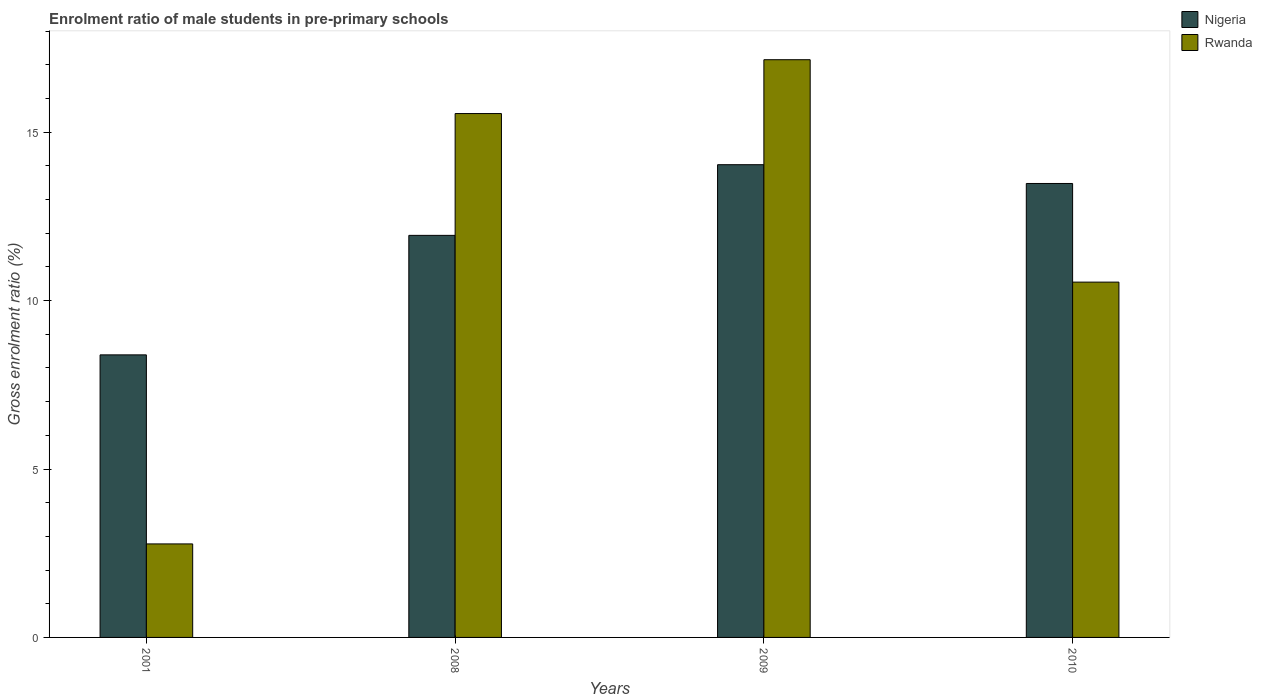How many groups of bars are there?
Your answer should be very brief. 4. Are the number of bars per tick equal to the number of legend labels?
Your answer should be very brief. Yes. How many bars are there on the 2nd tick from the left?
Your answer should be compact. 2. What is the label of the 4th group of bars from the left?
Provide a succinct answer. 2010. In how many cases, is the number of bars for a given year not equal to the number of legend labels?
Keep it short and to the point. 0. What is the enrolment ratio of male students in pre-primary schools in Nigeria in 2010?
Offer a terse response. 13.48. Across all years, what is the maximum enrolment ratio of male students in pre-primary schools in Nigeria?
Make the answer very short. 14.04. Across all years, what is the minimum enrolment ratio of male students in pre-primary schools in Rwanda?
Give a very brief answer. 2.78. In which year was the enrolment ratio of male students in pre-primary schools in Nigeria maximum?
Make the answer very short. 2009. In which year was the enrolment ratio of male students in pre-primary schools in Nigeria minimum?
Your answer should be very brief. 2001. What is the total enrolment ratio of male students in pre-primary schools in Nigeria in the graph?
Offer a terse response. 47.84. What is the difference between the enrolment ratio of male students in pre-primary schools in Nigeria in 2008 and that in 2010?
Ensure brevity in your answer.  -1.54. What is the difference between the enrolment ratio of male students in pre-primary schools in Rwanda in 2008 and the enrolment ratio of male students in pre-primary schools in Nigeria in 2001?
Provide a short and direct response. 7.16. What is the average enrolment ratio of male students in pre-primary schools in Rwanda per year?
Keep it short and to the point. 11.51. In the year 2010, what is the difference between the enrolment ratio of male students in pre-primary schools in Rwanda and enrolment ratio of male students in pre-primary schools in Nigeria?
Make the answer very short. -2.93. What is the ratio of the enrolment ratio of male students in pre-primary schools in Rwanda in 2008 to that in 2009?
Ensure brevity in your answer.  0.91. Is the difference between the enrolment ratio of male students in pre-primary schools in Rwanda in 2009 and 2010 greater than the difference between the enrolment ratio of male students in pre-primary schools in Nigeria in 2009 and 2010?
Provide a succinct answer. Yes. What is the difference between the highest and the second highest enrolment ratio of male students in pre-primary schools in Nigeria?
Provide a short and direct response. 0.56. What is the difference between the highest and the lowest enrolment ratio of male students in pre-primary schools in Nigeria?
Keep it short and to the point. 5.65. In how many years, is the enrolment ratio of male students in pre-primary schools in Nigeria greater than the average enrolment ratio of male students in pre-primary schools in Nigeria taken over all years?
Your answer should be compact. 2. Is the sum of the enrolment ratio of male students in pre-primary schools in Nigeria in 2009 and 2010 greater than the maximum enrolment ratio of male students in pre-primary schools in Rwanda across all years?
Your answer should be very brief. Yes. What does the 2nd bar from the left in 2009 represents?
Your answer should be very brief. Rwanda. What does the 1st bar from the right in 2001 represents?
Provide a succinct answer. Rwanda. How many bars are there?
Offer a very short reply. 8. How many years are there in the graph?
Offer a terse response. 4. What is the difference between two consecutive major ticks on the Y-axis?
Offer a terse response. 5. Where does the legend appear in the graph?
Your response must be concise. Top right. What is the title of the graph?
Ensure brevity in your answer.  Enrolment ratio of male students in pre-primary schools. Does "Malawi" appear as one of the legend labels in the graph?
Provide a short and direct response. No. What is the Gross enrolment ratio (%) in Nigeria in 2001?
Your answer should be compact. 8.39. What is the Gross enrolment ratio (%) in Rwanda in 2001?
Your answer should be compact. 2.78. What is the Gross enrolment ratio (%) in Nigeria in 2008?
Give a very brief answer. 11.94. What is the Gross enrolment ratio (%) in Rwanda in 2008?
Make the answer very short. 15.55. What is the Gross enrolment ratio (%) of Nigeria in 2009?
Offer a very short reply. 14.04. What is the Gross enrolment ratio (%) in Rwanda in 2009?
Offer a terse response. 17.15. What is the Gross enrolment ratio (%) of Nigeria in 2010?
Give a very brief answer. 13.48. What is the Gross enrolment ratio (%) of Rwanda in 2010?
Offer a terse response. 10.55. Across all years, what is the maximum Gross enrolment ratio (%) of Nigeria?
Make the answer very short. 14.04. Across all years, what is the maximum Gross enrolment ratio (%) of Rwanda?
Offer a terse response. 17.15. Across all years, what is the minimum Gross enrolment ratio (%) of Nigeria?
Offer a very short reply. 8.39. Across all years, what is the minimum Gross enrolment ratio (%) in Rwanda?
Give a very brief answer. 2.78. What is the total Gross enrolment ratio (%) of Nigeria in the graph?
Ensure brevity in your answer.  47.84. What is the total Gross enrolment ratio (%) in Rwanda in the graph?
Give a very brief answer. 46.03. What is the difference between the Gross enrolment ratio (%) of Nigeria in 2001 and that in 2008?
Your response must be concise. -3.55. What is the difference between the Gross enrolment ratio (%) of Rwanda in 2001 and that in 2008?
Your answer should be compact. -12.78. What is the difference between the Gross enrolment ratio (%) of Nigeria in 2001 and that in 2009?
Make the answer very short. -5.65. What is the difference between the Gross enrolment ratio (%) of Rwanda in 2001 and that in 2009?
Your answer should be very brief. -14.38. What is the difference between the Gross enrolment ratio (%) in Nigeria in 2001 and that in 2010?
Offer a terse response. -5.09. What is the difference between the Gross enrolment ratio (%) of Rwanda in 2001 and that in 2010?
Keep it short and to the point. -7.77. What is the difference between the Gross enrolment ratio (%) of Nigeria in 2008 and that in 2009?
Offer a very short reply. -2.1. What is the difference between the Gross enrolment ratio (%) in Rwanda in 2008 and that in 2009?
Provide a short and direct response. -1.6. What is the difference between the Gross enrolment ratio (%) in Nigeria in 2008 and that in 2010?
Your response must be concise. -1.54. What is the difference between the Gross enrolment ratio (%) of Rwanda in 2008 and that in 2010?
Ensure brevity in your answer.  5. What is the difference between the Gross enrolment ratio (%) in Nigeria in 2009 and that in 2010?
Give a very brief answer. 0.56. What is the difference between the Gross enrolment ratio (%) of Rwanda in 2009 and that in 2010?
Offer a very short reply. 6.6. What is the difference between the Gross enrolment ratio (%) in Nigeria in 2001 and the Gross enrolment ratio (%) in Rwanda in 2008?
Offer a very short reply. -7.16. What is the difference between the Gross enrolment ratio (%) in Nigeria in 2001 and the Gross enrolment ratio (%) in Rwanda in 2009?
Your response must be concise. -8.76. What is the difference between the Gross enrolment ratio (%) in Nigeria in 2001 and the Gross enrolment ratio (%) in Rwanda in 2010?
Your answer should be compact. -2.16. What is the difference between the Gross enrolment ratio (%) of Nigeria in 2008 and the Gross enrolment ratio (%) of Rwanda in 2009?
Make the answer very short. -5.22. What is the difference between the Gross enrolment ratio (%) of Nigeria in 2008 and the Gross enrolment ratio (%) of Rwanda in 2010?
Your response must be concise. 1.39. What is the difference between the Gross enrolment ratio (%) in Nigeria in 2009 and the Gross enrolment ratio (%) in Rwanda in 2010?
Keep it short and to the point. 3.49. What is the average Gross enrolment ratio (%) in Nigeria per year?
Provide a short and direct response. 11.96. What is the average Gross enrolment ratio (%) of Rwanda per year?
Offer a very short reply. 11.51. In the year 2001, what is the difference between the Gross enrolment ratio (%) in Nigeria and Gross enrolment ratio (%) in Rwanda?
Offer a terse response. 5.61. In the year 2008, what is the difference between the Gross enrolment ratio (%) of Nigeria and Gross enrolment ratio (%) of Rwanda?
Provide a succinct answer. -3.62. In the year 2009, what is the difference between the Gross enrolment ratio (%) of Nigeria and Gross enrolment ratio (%) of Rwanda?
Ensure brevity in your answer.  -3.12. In the year 2010, what is the difference between the Gross enrolment ratio (%) of Nigeria and Gross enrolment ratio (%) of Rwanda?
Offer a terse response. 2.93. What is the ratio of the Gross enrolment ratio (%) in Nigeria in 2001 to that in 2008?
Offer a very short reply. 0.7. What is the ratio of the Gross enrolment ratio (%) of Rwanda in 2001 to that in 2008?
Ensure brevity in your answer.  0.18. What is the ratio of the Gross enrolment ratio (%) in Nigeria in 2001 to that in 2009?
Make the answer very short. 0.6. What is the ratio of the Gross enrolment ratio (%) of Rwanda in 2001 to that in 2009?
Give a very brief answer. 0.16. What is the ratio of the Gross enrolment ratio (%) of Nigeria in 2001 to that in 2010?
Your response must be concise. 0.62. What is the ratio of the Gross enrolment ratio (%) of Rwanda in 2001 to that in 2010?
Provide a short and direct response. 0.26. What is the ratio of the Gross enrolment ratio (%) in Nigeria in 2008 to that in 2009?
Ensure brevity in your answer.  0.85. What is the ratio of the Gross enrolment ratio (%) of Rwanda in 2008 to that in 2009?
Your answer should be very brief. 0.91. What is the ratio of the Gross enrolment ratio (%) in Nigeria in 2008 to that in 2010?
Keep it short and to the point. 0.89. What is the ratio of the Gross enrolment ratio (%) in Rwanda in 2008 to that in 2010?
Offer a terse response. 1.47. What is the ratio of the Gross enrolment ratio (%) of Nigeria in 2009 to that in 2010?
Ensure brevity in your answer.  1.04. What is the ratio of the Gross enrolment ratio (%) in Rwanda in 2009 to that in 2010?
Your answer should be very brief. 1.63. What is the difference between the highest and the second highest Gross enrolment ratio (%) in Nigeria?
Your response must be concise. 0.56. What is the difference between the highest and the second highest Gross enrolment ratio (%) of Rwanda?
Offer a very short reply. 1.6. What is the difference between the highest and the lowest Gross enrolment ratio (%) in Nigeria?
Ensure brevity in your answer.  5.65. What is the difference between the highest and the lowest Gross enrolment ratio (%) of Rwanda?
Give a very brief answer. 14.38. 